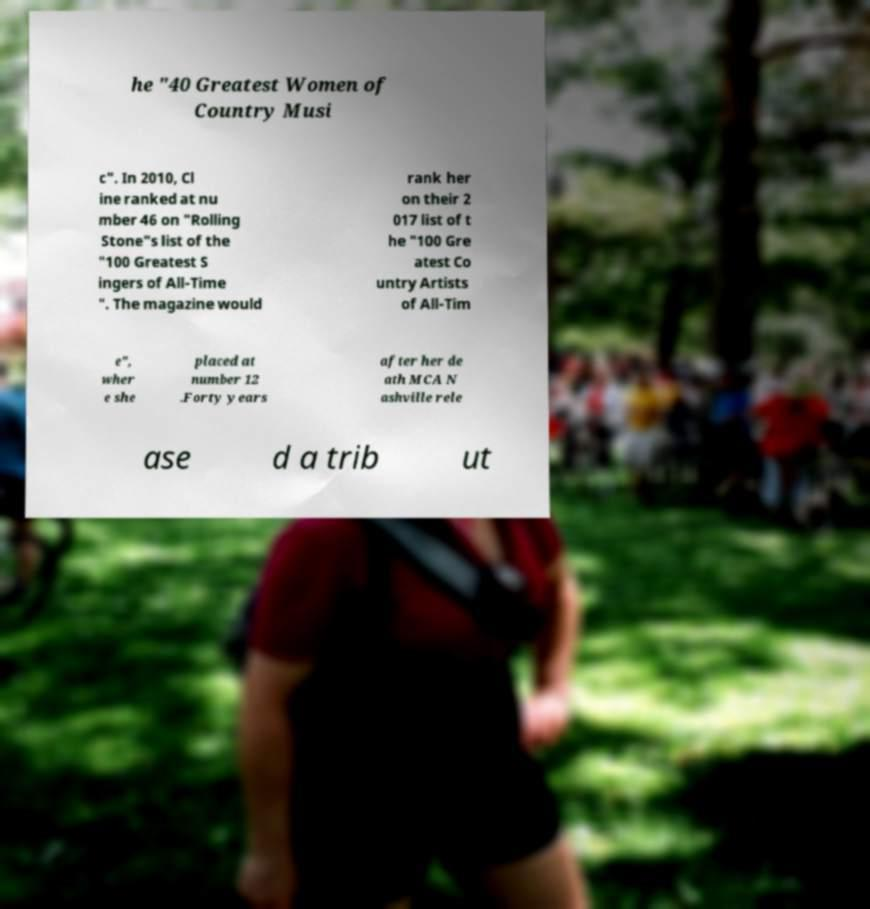There's text embedded in this image that I need extracted. Can you transcribe it verbatim? he "40 Greatest Women of Country Musi c". In 2010, Cl ine ranked at nu mber 46 on "Rolling Stone"s list of the "100 Greatest S ingers of All-Time ". The magazine would rank her on their 2 017 list of t he "100 Gre atest Co untry Artists of All-Tim e", wher e she placed at number 12 .Forty years after her de ath MCA N ashville rele ase d a trib ut 